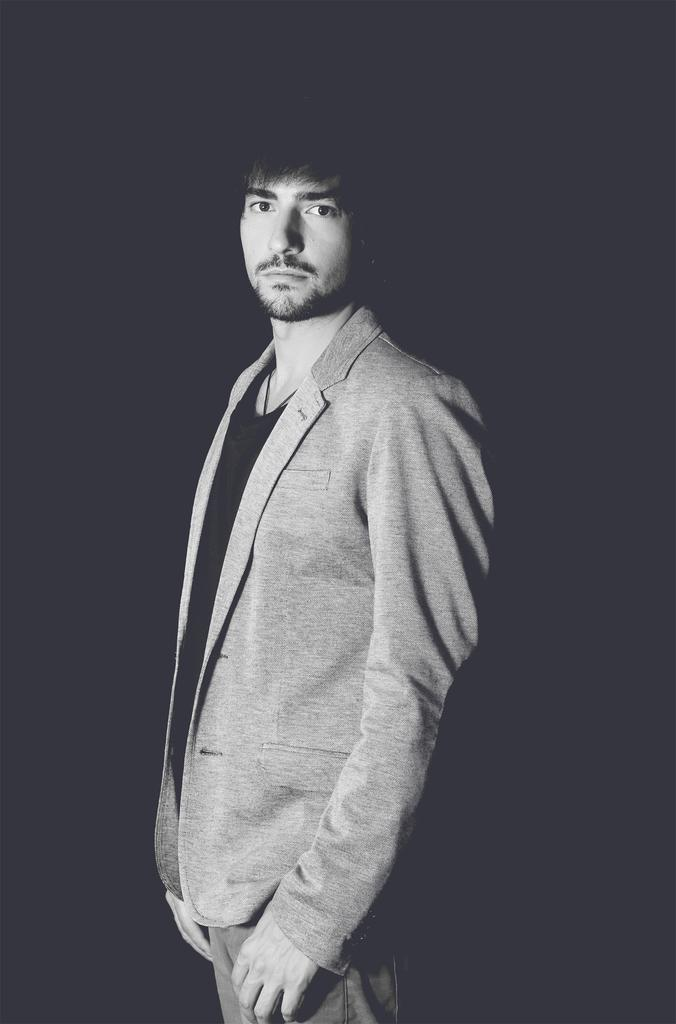What is the main subject of the image? The main subject of the image is a man standing. What is the man wearing in the image? The man is wearing a suit in the image. Can you describe the background of the image? The background of the image is dark. Is there a volcano erupting in the background of the image? No, there is no volcano present in the image. What type of sponge is the man using to clean the suit in the image? There is no sponge or cleaning activity depicted in the image. 